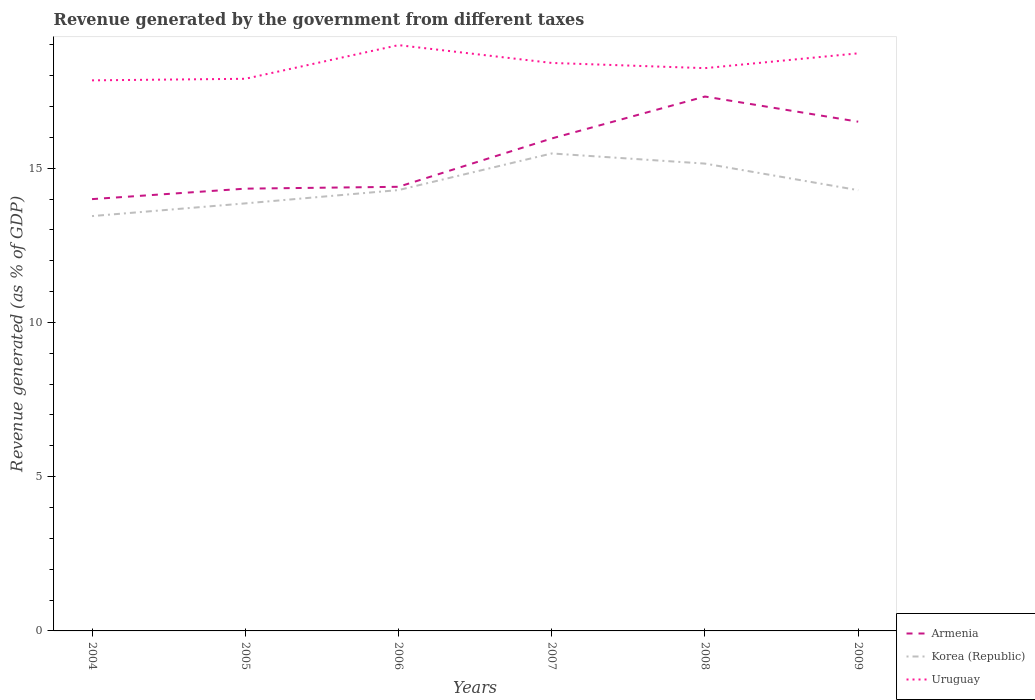How many different coloured lines are there?
Give a very brief answer. 3. Across all years, what is the maximum revenue generated by the government in Korea (Republic)?
Ensure brevity in your answer.  13.45. In which year was the revenue generated by the government in Armenia maximum?
Keep it short and to the point. 2004. What is the total revenue generated by the government in Uruguay in the graph?
Provide a succinct answer. 0.58. What is the difference between the highest and the second highest revenue generated by the government in Uruguay?
Your response must be concise. 1.14. What is the difference between two consecutive major ticks on the Y-axis?
Give a very brief answer. 5. Where does the legend appear in the graph?
Offer a very short reply. Bottom right. What is the title of the graph?
Provide a succinct answer. Revenue generated by the government from different taxes. What is the label or title of the X-axis?
Offer a terse response. Years. What is the label or title of the Y-axis?
Your answer should be compact. Revenue generated (as % of GDP). What is the Revenue generated (as % of GDP) of Armenia in 2004?
Offer a very short reply. 14. What is the Revenue generated (as % of GDP) of Korea (Republic) in 2004?
Keep it short and to the point. 13.45. What is the Revenue generated (as % of GDP) in Uruguay in 2004?
Your answer should be compact. 17.85. What is the Revenue generated (as % of GDP) of Armenia in 2005?
Offer a terse response. 14.34. What is the Revenue generated (as % of GDP) of Korea (Republic) in 2005?
Keep it short and to the point. 13.86. What is the Revenue generated (as % of GDP) of Uruguay in 2005?
Ensure brevity in your answer.  17.9. What is the Revenue generated (as % of GDP) in Armenia in 2006?
Keep it short and to the point. 14.4. What is the Revenue generated (as % of GDP) in Korea (Republic) in 2006?
Provide a short and direct response. 14.29. What is the Revenue generated (as % of GDP) in Uruguay in 2006?
Provide a short and direct response. 18.99. What is the Revenue generated (as % of GDP) in Armenia in 2007?
Make the answer very short. 15.96. What is the Revenue generated (as % of GDP) of Korea (Republic) in 2007?
Your response must be concise. 15.48. What is the Revenue generated (as % of GDP) in Uruguay in 2007?
Offer a terse response. 18.41. What is the Revenue generated (as % of GDP) in Armenia in 2008?
Make the answer very short. 17.32. What is the Revenue generated (as % of GDP) in Korea (Republic) in 2008?
Provide a succinct answer. 15.15. What is the Revenue generated (as % of GDP) in Uruguay in 2008?
Offer a very short reply. 18.24. What is the Revenue generated (as % of GDP) in Armenia in 2009?
Offer a very short reply. 16.51. What is the Revenue generated (as % of GDP) in Korea (Republic) in 2009?
Your response must be concise. 14.29. What is the Revenue generated (as % of GDP) of Uruguay in 2009?
Keep it short and to the point. 18.72. Across all years, what is the maximum Revenue generated (as % of GDP) in Armenia?
Offer a terse response. 17.32. Across all years, what is the maximum Revenue generated (as % of GDP) of Korea (Republic)?
Offer a terse response. 15.48. Across all years, what is the maximum Revenue generated (as % of GDP) of Uruguay?
Provide a succinct answer. 18.99. Across all years, what is the minimum Revenue generated (as % of GDP) in Armenia?
Your answer should be compact. 14. Across all years, what is the minimum Revenue generated (as % of GDP) of Korea (Republic)?
Your response must be concise. 13.45. Across all years, what is the minimum Revenue generated (as % of GDP) in Uruguay?
Give a very brief answer. 17.85. What is the total Revenue generated (as % of GDP) of Armenia in the graph?
Your response must be concise. 92.52. What is the total Revenue generated (as % of GDP) of Korea (Republic) in the graph?
Your answer should be very brief. 86.5. What is the total Revenue generated (as % of GDP) in Uruguay in the graph?
Keep it short and to the point. 110.11. What is the difference between the Revenue generated (as % of GDP) of Armenia in 2004 and that in 2005?
Make the answer very short. -0.34. What is the difference between the Revenue generated (as % of GDP) in Korea (Republic) in 2004 and that in 2005?
Provide a short and direct response. -0.41. What is the difference between the Revenue generated (as % of GDP) in Uruguay in 2004 and that in 2005?
Provide a succinct answer. -0.05. What is the difference between the Revenue generated (as % of GDP) of Armenia in 2004 and that in 2006?
Keep it short and to the point. -0.4. What is the difference between the Revenue generated (as % of GDP) of Korea (Republic) in 2004 and that in 2006?
Provide a succinct answer. -0.84. What is the difference between the Revenue generated (as % of GDP) of Uruguay in 2004 and that in 2006?
Offer a terse response. -1.14. What is the difference between the Revenue generated (as % of GDP) in Armenia in 2004 and that in 2007?
Your answer should be very brief. -1.97. What is the difference between the Revenue generated (as % of GDP) of Korea (Republic) in 2004 and that in 2007?
Ensure brevity in your answer.  -2.03. What is the difference between the Revenue generated (as % of GDP) of Uruguay in 2004 and that in 2007?
Make the answer very short. -0.56. What is the difference between the Revenue generated (as % of GDP) in Armenia in 2004 and that in 2008?
Provide a succinct answer. -3.33. What is the difference between the Revenue generated (as % of GDP) in Korea (Republic) in 2004 and that in 2008?
Your answer should be very brief. -1.7. What is the difference between the Revenue generated (as % of GDP) of Uruguay in 2004 and that in 2008?
Keep it short and to the point. -0.4. What is the difference between the Revenue generated (as % of GDP) of Armenia in 2004 and that in 2009?
Ensure brevity in your answer.  -2.51. What is the difference between the Revenue generated (as % of GDP) in Korea (Republic) in 2004 and that in 2009?
Keep it short and to the point. -0.84. What is the difference between the Revenue generated (as % of GDP) of Uruguay in 2004 and that in 2009?
Offer a terse response. -0.88. What is the difference between the Revenue generated (as % of GDP) in Armenia in 2005 and that in 2006?
Your answer should be compact. -0.06. What is the difference between the Revenue generated (as % of GDP) in Korea (Republic) in 2005 and that in 2006?
Make the answer very short. -0.43. What is the difference between the Revenue generated (as % of GDP) in Uruguay in 2005 and that in 2006?
Offer a very short reply. -1.09. What is the difference between the Revenue generated (as % of GDP) of Armenia in 2005 and that in 2007?
Your response must be concise. -1.63. What is the difference between the Revenue generated (as % of GDP) in Korea (Republic) in 2005 and that in 2007?
Provide a succinct answer. -1.62. What is the difference between the Revenue generated (as % of GDP) in Uruguay in 2005 and that in 2007?
Offer a very short reply. -0.51. What is the difference between the Revenue generated (as % of GDP) of Armenia in 2005 and that in 2008?
Your answer should be very brief. -2.99. What is the difference between the Revenue generated (as % of GDP) in Korea (Republic) in 2005 and that in 2008?
Offer a very short reply. -1.29. What is the difference between the Revenue generated (as % of GDP) of Uruguay in 2005 and that in 2008?
Keep it short and to the point. -0.34. What is the difference between the Revenue generated (as % of GDP) of Armenia in 2005 and that in 2009?
Your answer should be compact. -2.17. What is the difference between the Revenue generated (as % of GDP) of Korea (Republic) in 2005 and that in 2009?
Offer a terse response. -0.43. What is the difference between the Revenue generated (as % of GDP) of Uruguay in 2005 and that in 2009?
Make the answer very short. -0.83. What is the difference between the Revenue generated (as % of GDP) in Armenia in 2006 and that in 2007?
Your response must be concise. -1.57. What is the difference between the Revenue generated (as % of GDP) in Korea (Republic) in 2006 and that in 2007?
Keep it short and to the point. -1.19. What is the difference between the Revenue generated (as % of GDP) of Uruguay in 2006 and that in 2007?
Your answer should be compact. 0.58. What is the difference between the Revenue generated (as % of GDP) of Armenia in 2006 and that in 2008?
Your answer should be compact. -2.93. What is the difference between the Revenue generated (as % of GDP) in Korea (Republic) in 2006 and that in 2008?
Provide a succinct answer. -0.86. What is the difference between the Revenue generated (as % of GDP) in Uruguay in 2006 and that in 2008?
Make the answer very short. 0.75. What is the difference between the Revenue generated (as % of GDP) of Armenia in 2006 and that in 2009?
Offer a very short reply. -2.11. What is the difference between the Revenue generated (as % of GDP) in Korea (Republic) in 2006 and that in 2009?
Make the answer very short. 0. What is the difference between the Revenue generated (as % of GDP) in Uruguay in 2006 and that in 2009?
Your answer should be compact. 0.27. What is the difference between the Revenue generated (as % of GDP) in Armenia in 2007 and that in 2008?
Ensure brevity in your answer.  -1.36. What is the difference between the Revenue generated (as % of GDP) in Korea (Republic) in 2007 and that in 2008?
Your answer should be compact. 0.33. What is the difference between the Revenue generated (as % of GDP) in Uruguay in 2007 and that in 2008?
Your answer should be compact. 0.17. What is the difference between the Revenue generated (as % of GDP) in Armenia in 2007 and that in 2009?
Provide a succinct answer. -0.54. What is the difference between the Revenue generated (as % of GDP) of Korea (Republic) in 2007 and that in 2009?
Your answer should be very brief. 1.19. What is the difference between the Revenue generated (as % of GDP) of Uruguay in 2007 and that in 2009?
Give a very brief answer. -0.31. What is the difference between the Revenue generated (as % of GDP) in Armenia in 2008 and that in 2009?
Ensure brevity in your answer.  0.82. What is the difference between the Revenue generated (as % of GDP) of Korea (Republic) in 2008 and that in 2009?
Your response must be concise. 0.86. What is the difference between the Revenue generated (as % of GDP) in Uruguay in 2008 and that in 2009?
Give a very brief answer. -0.48. What is the difference between the Revenue generated (as % of GDP) of Armenia in 2004 and the Revenue generated (as % of GDP) of Korea (Republic) in 2005?
Your response must be concise. 0.14. What is the difference between the Revenue generated (as % of GDP) in Armenia in 2004 and the Revenue generated (as % of GDP) in Uruguay in 2005?
Give a very brief answer. -3.9. What is the difference between the Revenue generated (as % of GDP) of Korea (Republic) in 2004 and the Revenue generated (as % of GDP) of Uruguay in 2005?
Your answer should be very brief. -4.45. What is the difference between the Revenue generated (as % of GDP) in Armenia in 2004 and the Revenue generated (as % of GDP) in Korea (Republic) in 2006?
Your answer should be compact. -0.29. What is the difference between the Revenue generated (as % of GDP) in Armenia in 2004 and the Revenue generated (as % of GDP) in Uruguay in 2006?
Make the answer very short. -4.99. What is the difference between the Revenue generated (as % of GDP) of Korea (Republic) in 2004 and the Revenue generated (as % of GDP) of Uruguay in 2006?
Ensure brevity in your answer.  -5.54. What is the difference between the Revenue generated (as % of GDP) of Armenia in 2004 and the Revenue generated (as % of GDP) of Korea (Republic) in 2007?
Offer a very short reply. -1.48. What is the difference between the Revenue generated (as % of GDP) in Armenia in 2004 and the Revenue generated (as % of GDP) in Uruguay in 2007?
Provide a short and direct response. -4.41. What is the difference between the Revenue generated (as % of GDP) in Korea (Republic) in 2004 and the Revenue generated (as % of GDP) in Uruguay in 2007?
Give a very brief answer. -4.96. What is the difference between the Revenue generated (as % of GDP) of Armenia in 2004 and the Revenue generated (as % of GDP) of Korea (Republic) in 2008?
Keep it short and to the point. -1.15. What is the difference between the Revenue generated (as % of GDP) in Armenia in 2004 and the Revenue generated (as % of GDP) in Uruguay in 2008?
Your answer should be very brief. -4.25. What is the difference between the Revenue generated (as % of GDP) of Korea (Republic) in 2004 and the Revenue generated (as % of GDP) of Uruguay in 2008?
Your answer should be compact. -4.8. What is the difference between the Revenue generated (as % of GDP) of Armenia in 2004 and the Revenue generated (as % of GDP) of Korea (Republic) in 2009?
Provide a short and direct response. -0.29. What is the difference between the Revenue generated (as % of GDP) of Armenia in 2004 and the Revenue generated (as % of GDP) of Uruguay in 2009?
Provide a succinct answer. -4.73. What is the difference between the Revenue generated (as % of GDP) in Korea (Republic) in 2004 and the Revenue generated (as % of GDP) in Uruguay in 2009?
Give a very brief answer. -5.28. What is the difference between the Revenue generated (as % of GDP) in Armenia in 2005 and the Revenue generated (as % of GDP) in Korea (Republic) in 2006?
Keep it short and to the point. 0.05. What is the difference between the Revenue generated (as % of GDP) of Armenia in 2005 and the Revenue generated (as % of GDP) of Uruguay in 2006?
Make the answer very short. -4.65. What is the difference between the Revenue generated (as % of GDP) in Korea (Republic) in 2005 and the Revenue generated (as % of GDP) in Uruguay in 2006?
Offer a terse response. -5.13. What is the difference between the Revenue generated (as % of GDP) of Armenia in 2005 and the Revenue generated (as % of GDP) of Korea (Republic) in 2007?
Offer a terse response. -1.14. What is the difference between the Revenue generated (as % of GDP) of Armenia in 2005 and the Revenue generated (as % of GDP) of Uruguay in 2007?
Your answer should be very brief. -4.07. What is the difference between the Revenue generated (as % of GDP) of Korea (Republic) in 2005 and the Revenue generated (as % of GDP) of Uruguay in 2007?
Offer a terse response. -4.55. What is the difference between the Revenue generated (as % of GDP) in Armenia in 2005 and the Revenue generated (as % of GDP) in Korea (Republic) in 2008?
Make the answer very short. -0.81. What is the difference between the Revenue generated (as % of GDP) in Armenia in 2005 and the Revenue generated (as % of GDP) in Uruguay in 2008?
Your response must be concise. -3.91. What is the difference between the Revenue generated (as % of GDP) in Korea (Republic) in 2005 and the Revenue generated (as % of GDP) in Uruguay in 2008?
Offer a terse response. -4.38. What is the difference between the Revenue generated (as % of GDP) in Armenia in 2005 and the Revenue generated (as % of GDP) in Korea (Republic) in 2009?
Give a very brief answer. 0.05. What is the difference between the Revenue generated (as % of GDP) of Armenia in 2005 and the Revenue generated (as % of GDP) of Uruguay in 2009?
Keep it short and to the point. -4.39. What is the difference between the Revenue generated (as % of GDP) in Korea (Republic) in 2005 and the Revenue generated (as % of GDP) in Uruguay in 2009?
Your response must be concise. -4.86. What is the difference between the Revenue generated (as % of GDP) of Armenia in 2006 and the Revenue generated (as % of GDP) of Korea (Republic) in 2007?
Your answer should be compact. -1.08. What is the difference between the Revenue generated (as % of GDP) of Armenia in 2006 and the Revenue generated (as % of GDP) of Uruguay in 2007?
Offer a terse response. -4.01. What is the difference between the Revenue generated (as % of GDP) in Korea (Republic) in 2006 and the Revenue generated (as % of GDP) in Uruguay in 2007?
Ensure brevity in your answer.  -4.12. What is the difference between the Revenue generated (as % of GDP) of Armenia in 2006 and the Revenue generated (as % of GDP) of Korea (Republic) in 2008?
Your response must be concise. -0.75. What is the difference between the Revenue generated (as % of GDP) in Armenia in 2006 and the Revenue generated (as % of GDP) in Uruguay in 2008?
Your response must be concise. -3.85. What is the difference between the Revenue generated (as % of GDP) in Korea (Republic) in 2006 and the Revenue generated (as % of GDP) in Uruguay in 2008?
Ensure brevity in your answer.  -3.95. What is the difference between the Revenue generated (as % of GDP) of Armenia in 2006 and the Revenue generated (as % of GDP) of Korea (Republic) in 2009?
Ensure brevity in your answer.  0.11. What is the difference between the Revenue generated (as % of GDP) in Armenia in 2006 and the Revenue generated (as % of GDP) in Uruguay in 2009?
Offer a very short reply. -4.33. What is the difference between the Revenue generated (as % of GDP) in Korea (Republic) in 2006 and the Revenue generated (as % of GDP) in Uruguay in 2009?
Your answer should be compact. -4.43. What is the difference between the Revenue generated (as % of GDP) in Armenia in 2007 and the Revenue generated (as % of GDP) in Korea (Republic) in 2008?
Your answer should be compact. 0.81. What is the difference between the Revenue generated (as % of GDP) of Armenia in 2007 and the Revenue generated (as % of GDP) of Uruguay in 2008?
Your response must be concise. -2.28. What is the difference between the Revenue generated (as % of GDP) in Korea (Republic) in 2007 and the Revenue generated (as % of GDP) in Uruguay in 2008?
Offer a terse response. -2.77. What is the difference between the Revenue generated (as % of GDP) in Armenia in 2007 and the Revenue generated (as % of GDP) in Korea (Republic) in 2009?
Provide a short and direct response. 1.68. What is the difference between the Revenue generated (as % of GDP) in Armenia in 2007 and the Revenue generated (as % of GDP) in Uruguay in 2009?
Provide a short and direct response. -2.76. What is the difference between the Revenue generated (as % of GDP) in Korea (Republic) in 2007 and the Revenue generated (as % of GDP) in Uruguay in 2009?
Make the answer very short. -3.25. What is the difference between the Revenue generated (as % of GDP) of Armenia in 2008 and the Revenue generated (as % of GDP) of Korea (Republic) in 2009?
Make the answer very short. 3.04. What is the difference between the Revenue generated (as % of GDP) in Armenia in 2008 and the Revenue generated (as % of GDP) in Uruguay in 2009?
Offer a terse response. -1.4. What is the difference between the Revenue generated (as % of GDP) in Korea (Republic) in 2008 and the Revenue generated (as % of GDP) in Uruguay in 2009?
Provide a succinct answer. -3.57. What is the average Revenue generated (as % of GDP) in Armenia per year?
Your response must be concise. 15.42. What is the average Revenue generated (as % of GDP) in Korea (Republic) per year?
Provide a short and direct response. 14.42. What is the average Revenue generated (as % of GDP) of Uruguay per year?
Make the answer very short. 18.35. In the year 2004, what is the difference between the Revenue generated (as % of GDP) in Armenia and Revenue generated (as % of GDP) in Korea (Republic)?
Your answer should be compact. 0.55. In the year 2004, what is the difference between the Revenue generated (as % of GDP) of Armenia and Revenue generated (as % of GDP) of Uruguay?
Keep it short and to the point. -3.85. In the year 2004, what is the difference between the Revenue generated (as % of GDP) of Korea (Republic) and Revenue generated (as % of GDP) of Uruguay?
Offer a very short reply. -4.4. In the year 2005, what is the difference between the Revenue generated (as % of GDP) of Armenia and Revenue generated (as % of GDP) of Korea (Republic)?
Your answer should be compact. 0.48. In the year 2005, what is the difference between the Revenue generated (as % of GDP) in Armenia and Revenue generated (as % of GDP) in Uruguay?
Provide a short and direct response. -3.56. In the year 2005, what is the difference between the Revenue generated (as % of GDP) in Korea (Republic) and Revenue generated (as % of GDP) in Uruguay?
Your answer should be very brief. -4.04. In the year 2006, what is the difference between the Revenue generated (as % of GDP) in Armenia and Revenue generated (as % of GDP) in Korea (Republic)?
Provide a succinct answer. 0.11. In the year 2006, what is the difference between the Revenue generated (as % of GDP) in Armenia and Revenue generated (as % of GDP) in Uruguay?
Offer a terse response. -4.59. In the year 2006, what is the difference between the Revenue generated (as % of GDP) of Korea (Republic) and Revenue generated (as % of GDP) of Uruguay?
Your answer should be very brief. -4.7. In the year 2007, what is the difference between the Revenue generated (as % of GDP) of Armenia and Revenue generated (as % of GDP) of Korea (Republic)?
Keep it short and to the point. 0.49. In the year 2007, what is the difference between the Revenue generated (as % of GDP) of Armenia and Revenue generated (as % of GDP) of Uruguay?
Your answer should be very brief. -2.45. In the year 2007, what is the difference between the Revenue generated (as % of GDP) of Korea (Republic) and Revenue generated (as % of GDP) of Uruguay?
Provide a succinct answer. -2.93. In the year 2008, what is the difference between the Revenue generated (as % of GDP) in Armenia and Revenue generated (as % of GDP) in Korea (Republic)?
Ensure brevity in your answer.  2.17. In the year 2008, what is the difference between the Revenue generated (as % of GDP) of Armenia and Revenue generated (as % of GDP) of Uruguay?
Give a very brief answer. -0.92. In the year 2008, what is the difference between the Revenue generated (as % of GDP) in Korea (Republic) and Revenue generated (as % of GDP) in Uruguay?
Provide a succinct answer. -3.09. In the year 2009, what is the difference between the Revenue generated (as % of GDP) in Armenia and Revenue generated (as % of GDP) in Korea (Republic)?
Your answer should be very brief. 2.22. In the year 2009, what is the difference between the Revenue generated (as % of GDP) of Armenia and Revenue generated (as % of GDP) of Uruguay?
Offer a very short reply. -2.22. In the year 2009, what is the difference between the Revenue generated (as % of GDP) of Korea (Republic) and Revenue generated (as % of GDP) of Uruguay?
Offer a very short reply. -4.44. What is the ratio of the Revenue generated (as % of GDP) in Armenia in 2004 to that in 2005?
Provide a short and direct response. 0.98. What is the ratio of the Revenue generated (as % of GDP) in Korea (Republic) in 2004 to that in 2005?
Give a very brief answer. 0.97. What is the ratio of the Revenue generated (as % of GDP) of Armenia in 2004 to that in 2006?
Offer a very short reply. 0.97. What is the ratio of the Revenue generated (as % of GDP) in Korea (Republic) in 2004 to that in 2006?
Give a very brief answer. 0.94. What is the ratio of the Revenue generated (as % of GDP) in Uruguay in 2004 to that in 2006?
Give a very brief answer. 0.94. What is the ratio of the Revenue generated (as % of GDP) in Armenia in 2004 to that in 2007?
Make the answer very short. 0.88. What is the ratio of the Revenue generated (as % of GDP) in Korea (Republic) in 2004 to that in 2007?
Offer a very short reply. 0.87. What is the ratio of the Revenue generated (as % of GDP) of Uruguay in 2004 to that in 2007?
Give a very brief answer. 0.97. What is the ratio of the Revenue generated (as % of GDP) in Armenia in 2004 to that in 2008?
Offer a very short reply. 0.81. What is the ratio of the Revenue generated (as % of GDP) in Korea (Republic) in 2004 to that in 2008?
Provide a short and direct response. 0.89. What is the ratio of the Revenue generated (as % of GDP) of Uruguay in 2004 to that in 2008?
Provide a succinct answer. 0.98. What is the ratio of the Revenue generated (as % of GDP) in Armenia in 2004 to that in 2009?
Your answer should be very brief. 0.85. What is the ratio of the Revenue generated (as % of GDP) of Uruguay in 2004 to that in 2009?
Your answer should be compact. 0.95. What is the ratio of the Revenue generated (as % of GDP) in Armenia in 2005 to that in 2006?
Ensure brevity in your answer.  1. What is the ratio of the Revenue generated (as % of GDP) in Korea (Republic) in 2005 to that in 2006?
Offer a very short reply. 0.97. What is the ratio of the Revenue generated (as % of GDP) in Uruguay in 2005 to that in 2006?
Offer a terse response. 0.94. What is the ratio of the Revenue generated (as % of GDP) in Armenia in 2005 to that in 2007?
Ensure brevity in your answer.  0.9. What is the ratio of the Revenue generated (as % of GDP) in Korea (Republic) in 2005 to that in 2007?
Your answer should be compact. 0.9. What is the ratio of the Revenue generated (as % of GDP) of Uruguay in 2005 to that in 2007?
Offer a very short reply. 0.97. What is the ratio of the Revenue generated (as % of GDP) of Armenia in 2005 to that in 2008?
Provide a succinct answer. 0.83. What is the ratio of the Revenue generated (as % of GDP) of Korea (Republic) in 2005 to that in 2008?
Offer a terse response. 0.91. What is the ratio of the Revenue generated (as % of GDP) in Uruguay in 2005 to that in 2008?
Ensure brevity in your answer.  0.98. What is the ratio of the Revenue generated (as % of GDP) of Armenia in 2005 to that in 2009?
Offer a terse response. 0.87. What is the ratio of the Revenue generated (as % of GDP) of Uruguay in 2005 to that in 2009?
Provide a succinct answer. 0.96. What is the ratio of the Revenue generated (as % of GDP) in Armenia in 2006 to that in 2007?
Your answer should be very brief. 0.9. What is the ratio of the Revenue generated (as % of GDP) in Korea (Republic) in 2006 to that in 2007?
Your answer should be compact. 0.92. What is the ratio of the Revenue generated (as % of GDP) in Uruguay in 2006 to that in 2007?
Your answer should be very brief. 1.03. What is the ratio of the Revenue generated (as % of GDP) in Armenia in 2006 to that in 2008?
Ensure brevity in your answer.  0.83. What is the ratio of the Revenue generated (as % of GDP) in Korea (Republic) in 2006 to that in 2008?
Provide a short and direct response. 0.94. What is the ratio of the Revenue generated (as % of GDP) of Uruguay in 2006 to that in 2008?
Provide a succinct answer. 1.04. What is the ratio of the Revenue generated (as % of GDP) in Armenia in 2006 to that in 2009?
Your answer should be compact. 0.87. What is the ratio of the Revenue generated (as % of GDP) of Uruguay in 2006 to that in 2009?
Keep it short and to the point. 1.01. What is the ratio of the Revenue generated (as % of GDP) in Armenia in 2007 to that in 2008?
Give a very brief answer. 0.92. What is the ratio of the Revenue generated (as % of GDP) of Korea (Republic) in 2007 to that in 2008?
Your answer should be very brief. 1.02. What is the ratio of the Revenue generated (as % of GDP) in Uruguay in 2007 to that in 2008?
Offer a terse response. 1.01. What is the ratio of the Revenue generated (as % of GDP) in Armenia in 2007 to that in 2009?
Provide a succinct answer. 0.97. What is the ratio of the Revenue generated (as % of GDP) in Korea (Republic) in 2007 to that in 2009?
Your response must be concise. 1.08. What is the ratio of the Revenue generated (as % of GDP) of Uruguay in 2007 to that in 2009?
Your answer should be compact. 0.98. What is the ratio of the Revenue generated (as % of GDP) in Armenia in 2008 to that in 2009?
Your answer should be very brief. 1.05. What is the ratio of the Revenue generated (as % of GDP) of Korea (Republic) in 2008 to that in 2009?
Ensure brevity in your answer.  1.06. What is the ratio of the Revenue generated (as % of GDP) in Uruguay in 2008 to that in 2009?
Provide a succinct answer. 0.97. What is the difference between the highest and the second highest Revenue generated (as % of GDP) of Armenia?
Offer a very short reply. 0.82. What is the difference between the highest and the second highest Revenue generated (as % of GDP) in Korea (Republic)?
Your answer should be very brief. 0.33. What is the difference between the highest and the second highest Revenue generated (as % of GDP) in Uruguay?
Your answer should be compact. 0.27. What is the difference between the highest and the lowest Revenue generated (as % of GDP) of Armenia?
Keep it short and to the point. 3.33. What is the difference between the highest and the lowest Revenue generated (as % of GDP) of Korea (Republic)?
Offer a terse response. 2.03. What is the difference between the highest and the lowest Revenue generated (as % of GDP) in Uruguay?
Offer a very short reply. 1.14. 